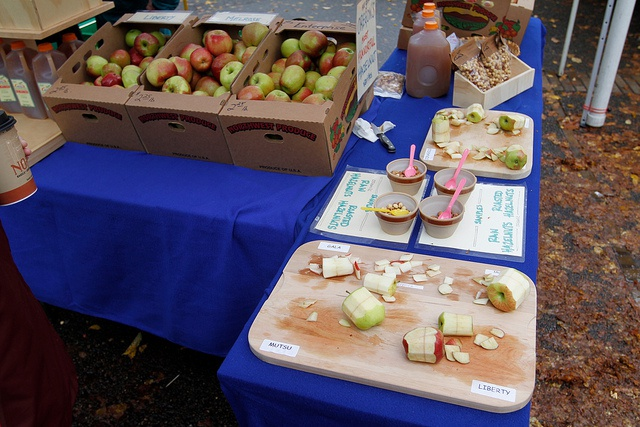Describe the objects in this image and their specific colors. I can see apple in gray, beige, and tan tones, apple in gray, olive, and black tones, apple in gray, tan, brown, and maroon tones, bottle in gray, maroon, brown, and black tones, and bottle in gray, maroon, brown, and black tones in this image. 